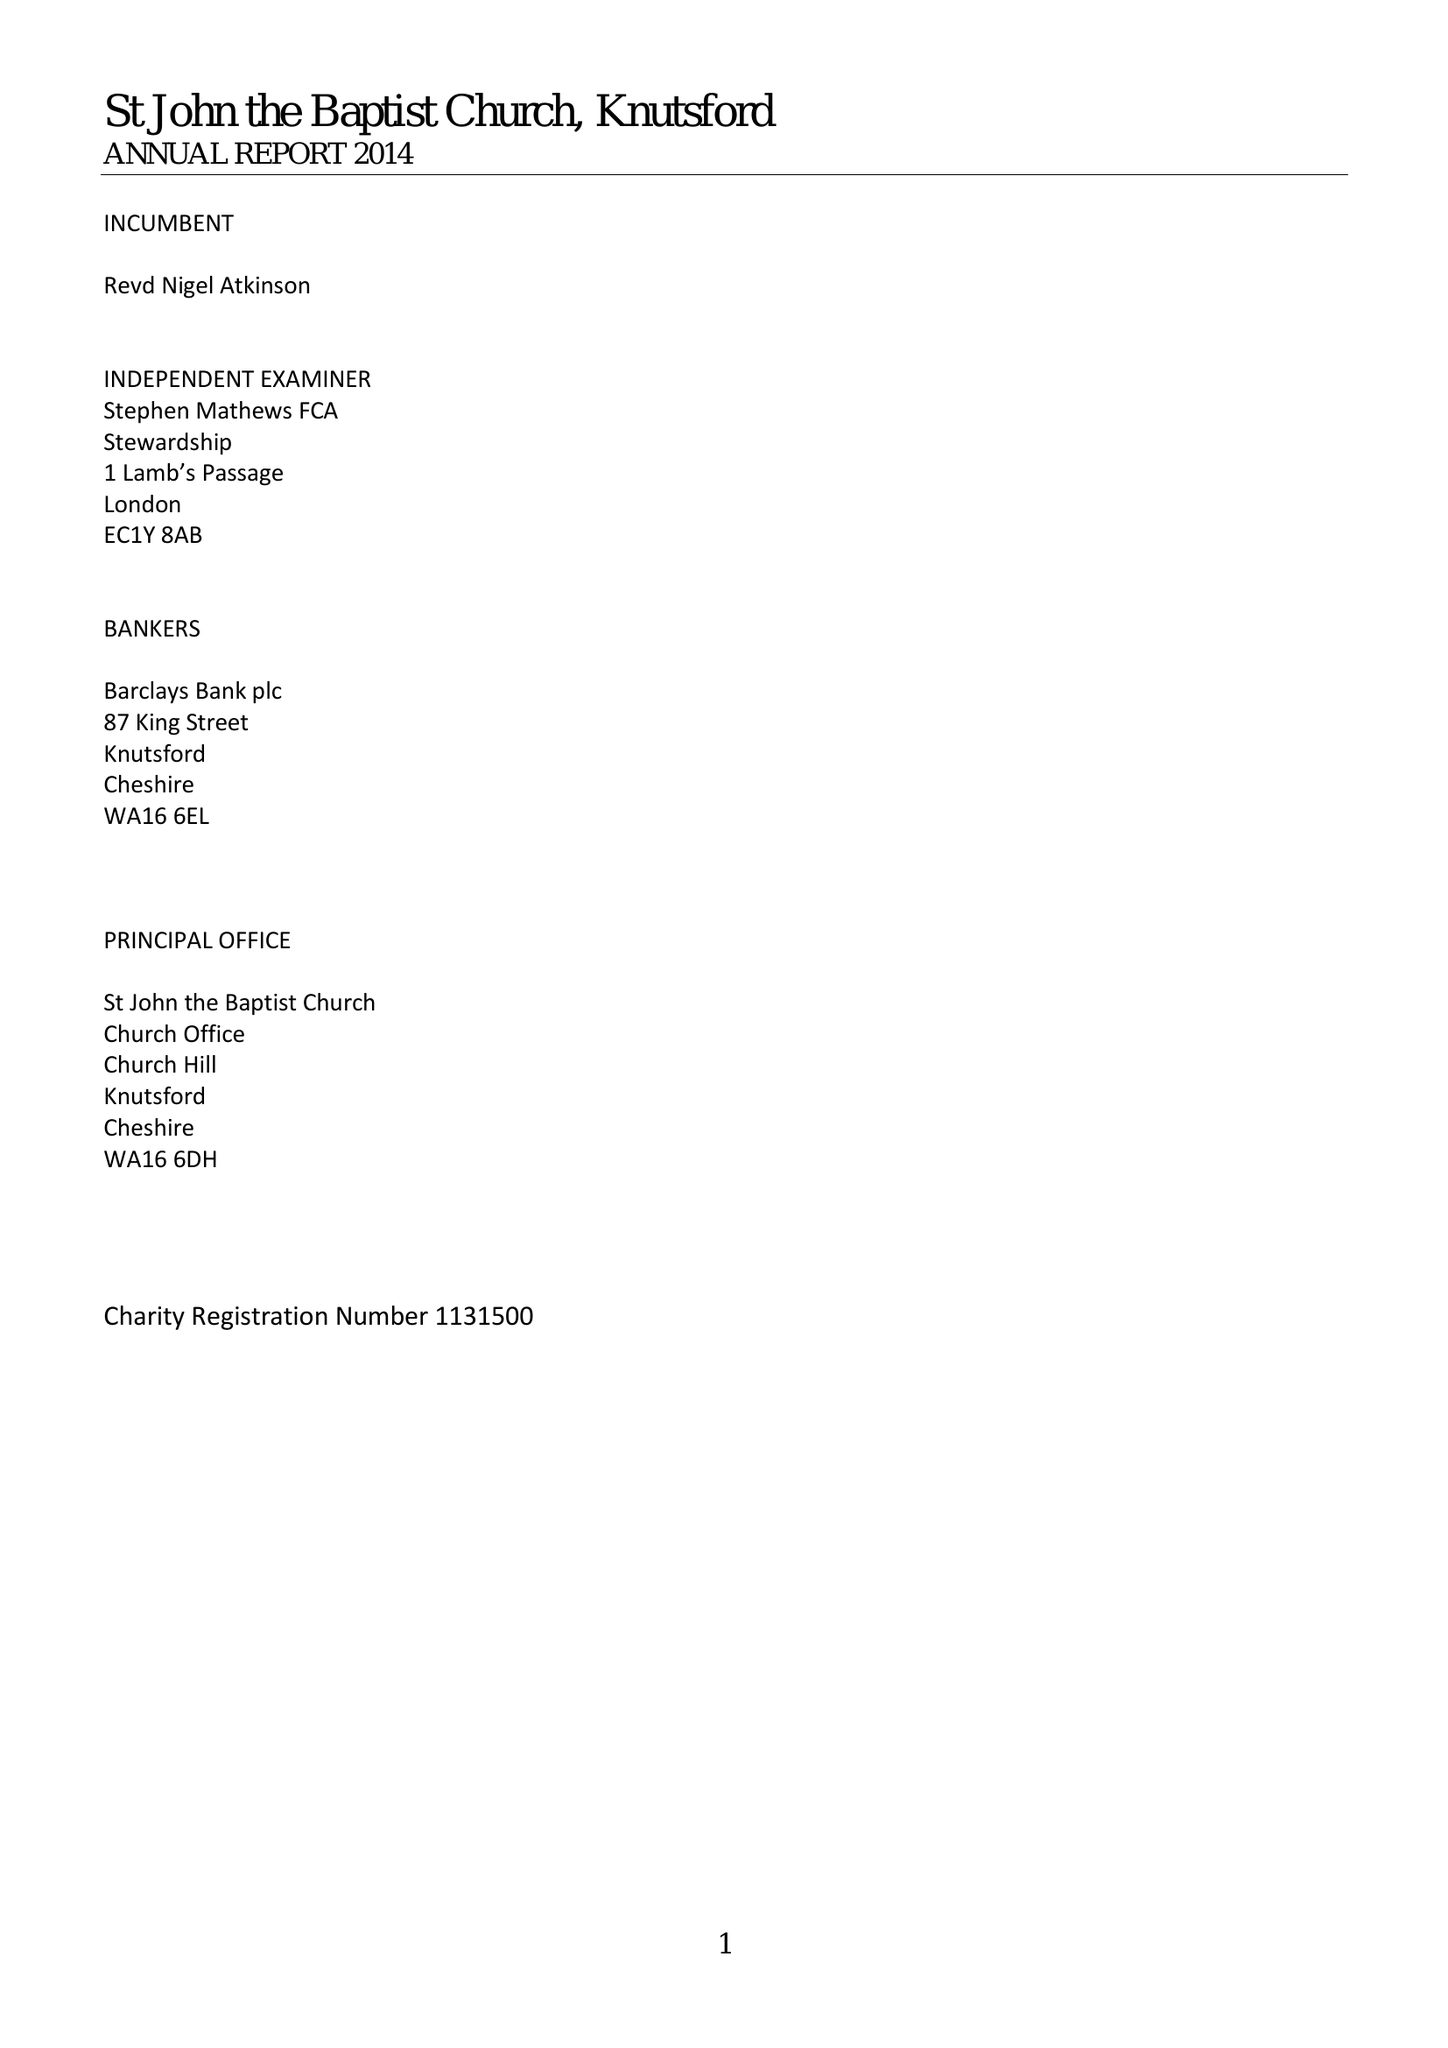What is the value for the address__postcode?
Answer the question using a single word or phrase. WA16 6DH 